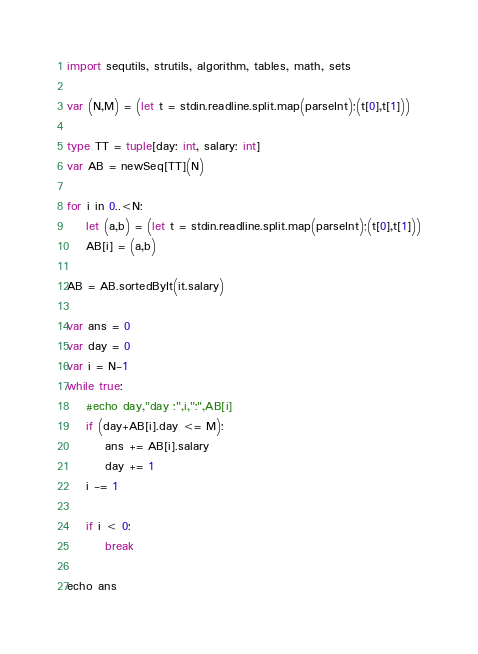Convert code to text. <code><loc_0><loc_0><loc_500><loc_500><_Nim_>import sequtils, strutils, algorithm, tables, math, sets

var (N,M) = (let t = stdin.readline.split.map(parseInt);(t[0],t[1]))

type TT = tuple[day: int, salary: int]
var AB = newSeq[TT](N)

for i in 0..<N:
    let (a,b) = (let t = stdin.readline.split.map(parseInt);(t[0],t[1]))
    AB[i] = (a,b)

AB = AB.sortedByIt(it.salary)

var ans = 0
var day = 0
var i = N-1
while true:
    #echo day,"day :",i,":",AB[i]
    if (day+AB[i].day <= M):
        ans += AB[i].salary
        day += 1
    i -= 1

    if i < 0:
        break

echo ans</code> 